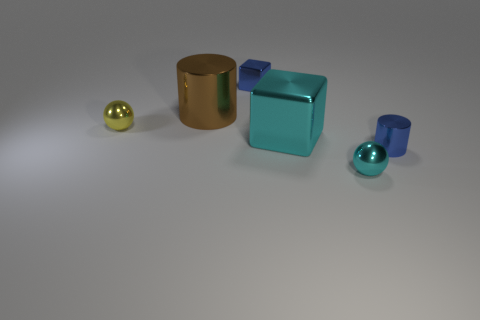How does the lighting in the scene affect the appearance of the objects? The lighting in the scene casts soft shadows and highlights the reflective properties of the objects giving them dimensionality and a realistic appearance.  What can you infer about the surface on which the objects are placed? The surface appears to be smooth and even, possibly made of a matte material that softly diffuses the light, providing a neutral background that emphasizes the objects. 